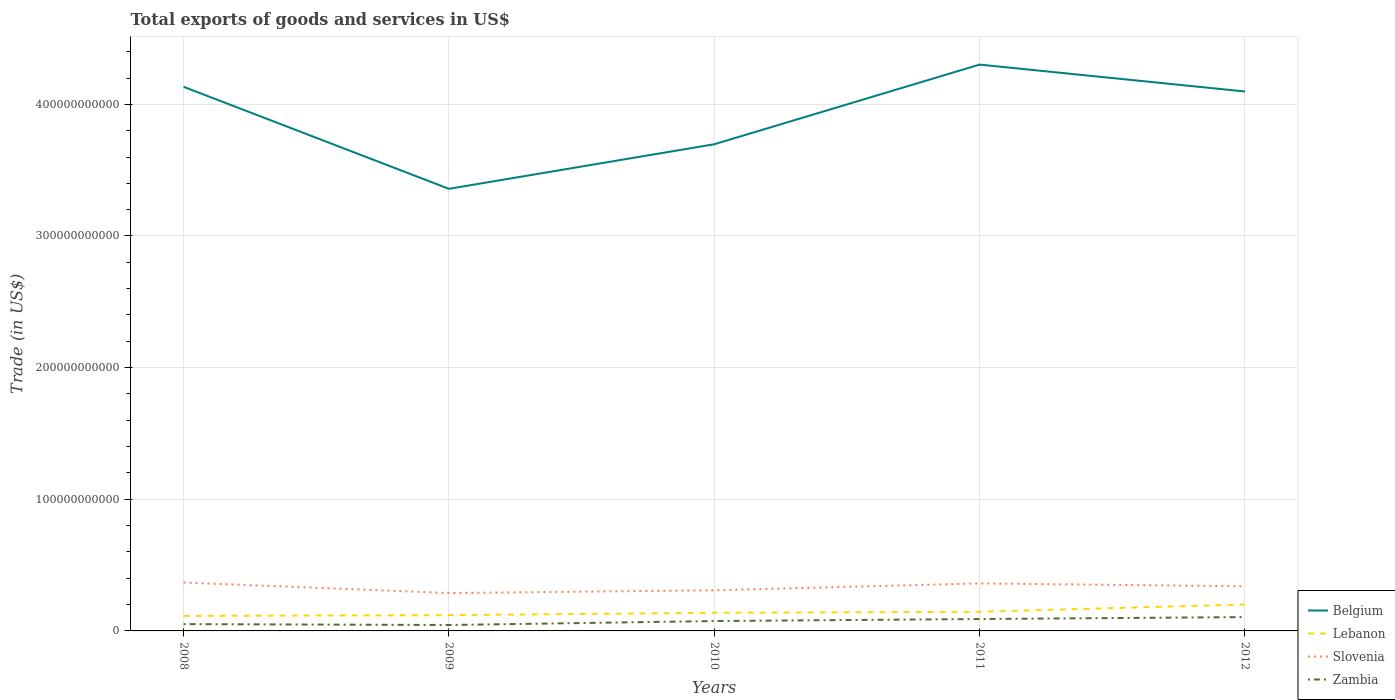Does the line corresponding to Belgium intersect with the line corresponding to Slovenia?
Your answer should be very brief. No. Is the number of lines equal to the number of legend labels?
Provide a succinct answer. Yes. Across all years, what is the maximum total exports of goods and services in Belgium?
Keep it short and to the point. 3.36e+11. In which year was the total exports of goods and services in Belgium maximum?
Provide a short and direct response. 2009. What is the total total exports of goods and services in Lebanon in the graph?
Your response must be concise. -3.09e+09. What is the difference between the highest and the second highest total exports of goods and services in Zambia?
Provide a short and direct response. 6.03e+09. What is the difference between two consecutive major ticks on the Y-axis?
Your answer should be very brief. 1.00e+11. Does the graph contain grids?
Offer a terse response. Yes. Where does the legend appear in the graph?
Provide a short and direct response. Bottom right. How are the legend labels stacked?
Give a very brief answer. Vertical. What is the title of the graph?
Offer a terse response. Total exports of goods and services in US$. Does "Turkey" appear as one of the legend labels in the graph?
Your answer should be compact. No. What is the label or title of the X-axis?
Make the answer very short. Years. What is the label or title of the Y-axis?
Ensure brevity in your answer.  Trade (in US$). What is the Trade (in US$) in Belgium in 2008?
Make the answer very short. 4.13e+11. What is the Trade (in US$) of Lebanon in 2008?
Make the answer very short. 1.14e+1. What is the Trade (in US$) of Slovenia in 2008?
Ensure brevity in your answer.  3.67e+1. What is the Trade (in US$) of Zambia in 2008?
Give a very brief answer. 5.18e+09. What is the Trade (in US$) of Belgium in 2009?
Offer a very short reply. 3.36e+11. What is the Trade (in US$) of Lebanon in 2009?
Keep it short and to the point. 1.20e+1. What is the Trade (in US$) in Slovenia in 2009?
Keep it short and to the point. 2.88e+1. What is the Trade (in US$) in Zambia in 2009?
Ensure brevity in your answer.  4.48e+09. What is the Trade (in US$) of Belgium in 2010?
Offer a very short reply. 3.70e+11. What is the Trade (in US$) in Lebanon in 2010?
Give a very brief answer. 1.38e+1. What is the Trade (in US$) in Slovenia in 2010?
Offer a very short reply. 3.09e+1. What is the Trade (in US$) of Zambia in 2010?
Your answer should be very brief. 7.50e+09. What is the Trade (in US$) in Belgium in 2011?
Your answer should be very brief. 4.30e+11. What is the Trade (in US$) of Lebanon in 2011?
Your response must be concise. 1.45e+1. What is the Trade (in US$) of Slovenia in 2011?
Ensure brevity in your answer.  3.61e+1. What is the Trade (in US$) of Zambia in 2011?
Your response must be concise. 9.03e+09. What is the Trade (in US$) in Belgium in 2012?
Your answer should be very brief. 4.10e+11. What is the Trade (in US$) of Lebanon in 2012?
Provide a succinct answer. 2.01e+1. What is the Trade (in US$) in Slovenia in 2012?
Provide a succinct answer. 3.39e+1. What is the Trade (in US$) in Zambia in 2012?
Ensure brevity in your answer.  1.05e+1. Across all years, what is the maximum Trade (in US$) in Belgium?
Your answer should be very brief. 4.30e+11. Across all years, what is the maximum Trade (in US$) in Lebanon?
Make the answer very short. 2.01e+1. Across all years, what is the maximum Trade (in US$) in Slovenia?
Provide a succinct answer. 3.67e+1. Across all years, what is the maximum Trade (in US$) in Zambia?
Give a very brief answer. 1.05e+1. Across all years, what is the minimum Trade (in US$) of Belgium?
Your answer should be very brief. 3.36e+11. Across all years, what is the minimum Trade (in US$) of Lebanon?
Provide a succinct answer. 1.14e+1. Across all years, what is the minimum Trade (in US$) of Slovenia?
Offer a terse response. 2.88e+1. Across all years, what is the minimum Trade (in US$) in Zambia?
Provide a succinct answer. 4.48e+09. What is the total Trade (in US$) in Belgium in the graph?
Give a very brief answer. 1.96e+12. What is the total Trade (in US$) of Lebanon in the graph?
Ensure brevity in your answer.  7.18e+1. What is the total Trade (in US$) of Slovenia in the graph?
Your answer should be compact. 1.66e+11. What is the total Trade (in US$) of Zambia in the graph?
Offer a very short reply. 3.67e+1. What is the difference between the Trade (in US$) of Belgium in 2008 and that in 2009?
Make the answer very short. 7.75e+1. What is the difference between the Trade (in US$) in Lebanon in 2008 and that in 2009?
Make the answer very short. -5.57e+08. What is the difference between the Trade (in US$) in Slovenia in 2008 and that in 2009?
Ensure brevity in your answer.  7.99e+09. What is the difference between the Trade (in US$) in Zambia in 2008 and that in 2009?
Your response must be concise. 6.96e+08. What is the difference between the Trade (in US$) of Belgium in 2008 and that in 2010?
Offer a very short reply. 4.36e+1. What is the difference between the Trade (in US$) of Lebanon in 2008 and that in 2010?
Your response must be concise. -2.35e+09. What is the difference between the Trade (in US$) of Slovenia in 2008 and that in 2010?
Provide a short and direct response. 5.88e+09. What is the difference between the Trade (in US$) of Zambia in 2008 and that in 2010?
Keep it short and to the point. -2.32e+09. What is the difference between the Trade (in US$) of Belgium in 2008 and that in 2011?
Make the answer very short. -1.69e+1. What is the difference between the Trade (in US$) of Lebanon in 2008 and that in 2011?
Offer a very short reply. -3.09e+09. What is the difference between the Trade (in US$) of Slovenia in 2008 and that in 2011?
Keep it short and to the point. 6.57e+08. What is the difference between the Trade (in US$) in Zambia in 2008 and that in 2011?
Your response must be concise. -3.85e+09. What is the difference between the Trade (in US$) in Belgium in 2008 and that in 2012?
Make the answer very short. 3.54e+09. What is the difference between the Trade (in US$) of Lebanon in 2008 and that in 2012?
Make the answer very short. -8.68e+09. What is the difference between the Trade (in US$) in Slovenia in 2008 and that in 2012?
Provide a succinct answer. 2.85e+09. What is the difference between the Trade (in US$) of Zambia in 2008 and that in 2012?
Give a very brief answer. -5.33e+09. What is the difference between the Trade (in US$) in Belgium in 2009 and that in 2010?
Keep it short and to the point. -3.38e+1. What is the difference between the Trade (in US$) in Lebanon in 2009 and that in 2010?
Offer a very short reply. -1.79e+09. What is the difference between the Trade (in US$) in Slovenia in 2009 and that in 2010?
Provide a succinct answer. -2.11e+09. What is the difference between the Trade (in US$) of Zambia in 2009 and that in 2010?
Provide a short and direct response. -3.02e+09. What is the difference between the Trade (in US$) in Belgium in 2009 and that in 2011?
Offer a terse response. -9.44e+1. What is the difference between the Trade (in US$) of Lebanon in 2009 and that in 2011?
Ensure brevity in your answer.  -2.53e+09. What is the difference between the Trade (in US$) of Slovenia in 2009 and that in 2011?
Provide a short and direct response. -7.33e+09. What is the difference between the Trade (in US$) in Zambia in 2009 and that in 2011?
Your response must be concise. -4.55e+09. What is the difference between the Trade (in US$) of Belgium in 2009 and that in 2012?
Your answer should be compact. -7.39e+1. What is the difference between the Trade (in US$) in Lebanon in 2009 and that in 2012?
Your response must be concise. -8.13e+09. What is the difference between the Trade (in US$) in Slovenia in 2009 and that in 2012?
Make the answer very short. -5.13e+09. What is the difference between the Trade (in US$) in Zambia in 2009 and that in 2012?
Your answer should be compact. -6.03e+09. What is the difference between the Trade (in US$) in Belgium in 2010 and that in 2011?
Give a very brief answer. -6.05e+1. What is the difference between the Trade (in US$) in Lebanon in 2010 and that in 2011?
Offer a terse response. -7.36e+08. What is the difference between the Trade (in US$) of Slovenia in 2010 and that in 2011?
Provide a short and direct response. -5.22e+09. What is the difference between the Trade (in US$) of Zambia in 2010 and that in 2011?
Offer a very short reply. -1.53e+09. What is the difference between the Trade (in US$) in Belgium in 2010 and that in 2012?
Make the answer very short. -4.01e+1. What is the difference between the Trade (in US$) of Lebanon in 2010 and that in 2012?
Make the answer very short. -6.33e+09. What is the difference between the Trade (in US$) of Slovenia in 2010 and that in 2012?
Your response must be concise. -3.03e+09. What is the difference between the Trade (in US$) in Zambia in 2010 and that in 2012?
Make the answer very short. -3.01e+09. What is the difference between the Trade (in US$) of Belgium in 2011 and that in 2012?
Make the answer very short. 2.04e+1. What is the difference between the Trade (in US$) of Lebanon in 2011 and that in 2012?
Your answer should be compact. -5.60e+09. What is the difference between the Trade (in US$) of Slovenia in 2011 and that in 2012?
Give a very brief answer. 2.20e+09. What is the difference between the Trade (in US$) of Zambia in 2011 and that in 2012?
Make the answer very short. -1.48e+09. What is the difference between the Trade (in US$) in Belgium in 2008 and the Trade (in US$) in Lebanon in 2009?
Your response must be concise. 4.01e+11. What is the difference between the Trade (in US$) of Belgium in 2008 and the Trade (in US$) of Slovenia in 2009?
Provide a succinct answer. 3.85e+11. What is the difference between the Trade (in US$) in Belgium in 2008 and the Trade (in US$) in Zambia in 2009?
Keep it short and to the point. 4.09e+11. What is the difference between the Trade (in US$) in Lebanon in 2008 and the Trade (in US$) in Slovenia in 2009?
Your answer should be very brief. -1.73e+1. What is the difference between the Trade (in US$) of Lebanon in 2008 and the Trade (in US$) of Zambia in 2009?
Offer a terse response. 6.95e+09. What is the difference between the Trade (in US$) in Slovenia in 2008 and the Trade (in US$) in Zambia in 2009?
Offer a terse response. 3.23e+1. What is the difference between the Trade (in US$) in Belgium in 2008 and the Trade (in US$) in Lebanon in 2010?
Your answer should be compact. 4.00e+11. What is the difference between the Trade (in US$) in Belgium in 2008 and the Trade (in US$) in Slovenia in 2010?
Offer a terse response. 3.82e+11. What is the difference between the Trade (in US$) in Belgium in 2008 and the Trade (in US$) in Zambia in 2010?
Provide a succinct answer. 4.06e+11. What is the difference between the Trade (in US$) in Lebanon in 2008 and the Trade (in US$) in Slovenia in 2010?
Your answer should be very brief. -1.94e+1. What is the difference between the Trade (in US$) in Lebanon in 2008 and the Trade (in US$) in Zambia in 2010?
Your answer should be very brief. 3.93e+09. What is the difference between the Trade (in US$) in Slovenia in 2008 and the Trade (in US$) in Zambia in 2010?
Provide a short and direct response. 2.92e+1. What is the difference between the Trade (in US$) of Belgium in 2008 and the Trade (in US$) of Lebanon in 2011?
Ensure brevity in your answer.  3.99e+11. What is the difference between the Trade (in US$) of Belgium in 2008 and the Trade (in US$) of Slovenia in 2011?
Provide a succinct answer. 3.77e+11. What is the difference between the Trade (in US$) in Belgium in 2008 and the Trade (in US$) in Zambia in 2011?
Offer a very short reply. 4.04e+11. What is the difference between the Trade (in US$) of Lebanon in 2008 and the Trade (in US$) of Slovenia in 2011?
Provide a short and direct response. -2.47e+1. What is the difference between the Trade (in US$) of Lebanon in 2008 and the Trade (in US$) of Zambia in 2011?
Ensure brevity in your answer.  2.40e+09. What is the difference between the Trade (in US$) in Slovenia in 2008 and the Trade (in US$) in Zambia in 2011?
Your answer should be compact. 2.77e+1. What is the difference between the Trade (in US$) of Belgium in 2008 and the Trade (in US$) of Lebanon in 2012?
Make the answer very short. 3.93e+11. What is the difference between the Trade (in US$) in Belgium in 2008 and the Trade (in US$) in Slovenia in 2012?
Your answer should be very brief. 3.79e+11. What is the difference between the Trade (in US$) in Belgium in 2008 and the Trade (in US$) in Zambia in 2012?
Your answer should be compact. 4.03e+11. What is the difference between the Trade (in US$) of Lebanon in 2008 and the Trade (in US$) of Slovenia in 2012?
Make the answer very short. -2.25e+1. What is the difference between the Trade (in US$) in Lebanon in 2008 and the Trade (in US$) in Zambia in 2012?
Give a very brief answer. 9.21e+08. What is the difference between the Trade (in US$) of Slovenia in 2008 and the Trade (in US$) of Zambia in 2012?
Provide a succinct answer. 2.62e+1. What is the difference between the Trade (in US$) of Belgium in 2009 and the Trade (in US$) of Lebanon in 2010?
Offer a very short reply. 3.22e+11. What is the difference between the Trade (in US$) of Belgium in 2009 and the Trade (in US$) of Slovenia in 2010?
Make the answer very short. 3.05e+11. What is the difference between the Trade (in US$) in Belgium in 2009 and the Trade (in US$) in Zambia in 2010?
Offer a very short reply. 3.28e+11. What is the difference between the Trade (in US$) in Lebanon in 2009 and the Trade (in US$) in Slovenia in 2010?
Your answer should be compact. -1.89e+1. What is the difference between the Trade (in US$) in Lebanon in 2009 and the Trade (in US$) in Zambia in 2010?
Offer a very short reply. 4.48e+09. What is the difference between the Trade (in US$) of Slovenia in 2009 and the Trade (in US$) of Zambia in 2010?
Provide a short and direct response. 2.13e+1. What is the difference between the Trade (in US$) in Belgium in 2009 and the Trade (in US$) in Lebanon in 2011?
Give a very brief answer. 3.21e+11. What is the difference between the Trade (in US$) in Belgium in 2009 and the Trade (in US$) in Slovenia in 2011?
Your answer should be very brief. 3.00e+11. What is the difference between the Trade (in US$) of Belgium in 2009 and the Trade (in US$) of Zambia in 2011?
Your answer should be very brief. 3.27e+11. What is the difference between the Trade (in US$) of Lebanon in 2009 and the Trade (in US$) of Slovenia in 2011?
Offer a very short reply. -2.41e+1. What is the difference between the Trade (in US$) in Lebanon in 2009 and the Trade (in US$) in Zambia in 2011?
Make the answer very short. 2.95e+09. What is the difference between the Trade (in US$) in Slovenia in 2009 and the Trade (in US$) in Zambia in 2011?
Provide a succinct answer. 1.97e+1. What is the difference between the Trade (in US$) of Belgium in 2009 and the Trade (in US$) of Lebanon in 2012?
Offer a very short reply. 3.16e+11. What is the difference between the Trade (in US$) of Belgium in 2009 and the Trade (in US$) of Slovenia in 2012?
Your answer should be very brief. 3.02e+11. What is the difference between the Trade (in US$) in Belgium in 2009 and the Trade (in US$) in Zambia in 2012?
Make the answer very short. 3.25e+11. What is the difference between the Trade (in US$) in Lebanon in 2009 and the Trade (in US$) in Slovenia in 2012?
Provide a succinct answer. -2.19e+1. What is the difference between the Trade (in US$) in Lebanon in 2009 and the Trade (in US$) in Zambia in 2012?
Offer a very short reply. 1.48e+09. What is the difference between the Trade (in US$) in Slovenia in 2009 and the Trade (in US$) in Zambia in 2012?
Your response must be concise. 1.83e+1. What is the difference between the Trade (in US$) of Belgium in 2010 and the Trade (in US$) of Lebanon in 2011?
Offer a very short reply. 3.55e+11. What is the difference between the Trade (in US$) of Belgium in 2010 and the Trade (in US$) of Slovenia in 2011?
Keep it short and to the point. 3.34e+11. What is the difference between the Trade (in US$) of Belgium in 2010 and the Trade (in US$) of Zambia in 2011?
Your answer should be very brief. 3.61e+11. What is the difference between the Trade (in US$) of Lebanon in 2010 and the Trade (in US$) of Slovenia in 2011?
Your response must be concise. -2.23e+1. What is the difference between the Trade (in US$) of Lebanon in 2010 and the Trade (in US$) of Zambia in 2011?
Your answer should be very brief. 4.75e+09. What is the difference between the Trade (in US$) in Slovenia in 2010 and the Trade (in US$) in Zambia in 2011?
Keep it short and to the point. 2.18e+1. What is the difference between the Trade (in US$) in Belgium in 2010 and the Trade (in US$) in Lebanon in 2012?
Ensure brevity in your answer.  3.50e+11. What is the difference between the Trade (in US$) of Belgium in 2010 and the Trade (in US$) of Slovenia in 2012?
Ensure brevity in your answer.  3.36e+11. What is the difference between the Trade (in US$) in Belgium in 2010 and the Trade (in US$) in Zambia in 2012?
Ensure brevity in your answer.  3.59e+11. What is the difference between the Trade (in US$) in Lebanon in 2010 and the Trade (in US$) in Slovenia in 2012?
Offer a very short reply. -2.01e+1. What is the difference between the Trade (in US$) of Lebanon in 2010 and the Trade (in US$) of Zambia in 2012?
Your response must be concise. 3.27e+09. What is the difference between the Trade (in US$) of Slovenia in 2010 and the Trade (in US$) of Zambia in 2012?
Your answer should be compact. 2.04e+1. What is the difference between the Trade (in US$) of Belgium in 2011 and the Trade (in US$) of Lebanon in 2012?
Provide a short and direct response. 4.10e+11. What is the difference between the Trade (in US$) in Belgium in 2011 and the Trade (in US$) in Slovenia in 2012?
Keep it short and to the point. 3.96e+11. What is the difference between the Trade (in US$) of Belgium in 2011 and the Trade (in US$) of Zambia in 2012?
Offer a very short reply. 4.20e+11. What is the difference between the Trade (in US$) in Lebanon in 2011 and the Trade (in US$) in Slovenia in 2012?
Offer a very short reply. -1.94e+1. What is the difference between the Trade (in US$) in Lebanon in 2011 and the Trade (in US$) in Zambia in 2012?
Ensure brevity in your answer.  4.01e+09. What is the difference between the Trade (in US$) of Slovenia in 2011 and the Trade (in US$) of Zambia in 2012?
Ensure brevity in your answer.  2.56e+1. What is the average Trade (in US$) in Belgium per year?
Make the answer very short. 3.92e+11. What is the average Trade (in US$) in Lebanon per year?
Give a very brief answer. 1.44e+1. What is the average Trade (in US$) in Slovenia per year?
Provide a succinct answer. 3.33e+1. What is the average Trade (in US$) in Zambia per year?
Your answer should be very brief. 7.34e+09. In the year 2008, what is the difference between the Trade (in US$) of Belgium and Trade (in US$) of Lebanon?
Ensure brevity in your answer.  4.02e+11. In the year 2008, what is the difference between the Trade (in US$) in Belgium and Trade (in US$) in Slovenia?
Offer a terse response. 3.77e+11. In the year 2008, what is the difference between the Trade (in US$) of Belgium and Trade (in US$) of Zambia?
Offer a very short reply. 4.08e+11. In the year 2008, what is the difference between the Trade (in US$) of Lebanon and Trade (in US$) of Slovenia?
Give a very brief answer. -2.53e+1. In the year 2008, what is the difference between the Trade (in US$) of Lebanon and Trade (in US$) of Zambia?
Ensure brevity in your answer.  6.25e+09. In the year 2008, what is the difference between the Trade (in US$) in Slovenia and Trade (in US$) in Zambia?
Provide a succinct answer. 3.16e+1. In the year 2009, what is the difference between the Trade (in US$) of Belgium and Trade (in US$) of Lebanon?
Provide a succinct answer. 3.24e+11. In the year 2009, what is the difference between the Trade (in US$) of Belgium and Trade (in US$) of Slovenia?
Keep it short and to the point. 3.07e+11. In the year 2009, what is the difference between the Trade (in US$) of Belgium and Trade (in US$) of Zambia?
Keep it short and to the point. 3.31e+11. In the year 2009, what is the difference between the Trade (in US$) in Lebanon and Trade (in US$) in Slovenia?
Give a very brief answer. -1.68e+1. In the year 2009, what is the difference between the Trade (in US$) in Lebanon and Trade (in US$) in Zambia?
Ensure brevity in your answer.  7.50e+09. In the year 2009, what is the difference between the Trade (in US$) of Slovenia and Trade (in US$) of Zambia?
Make the answer very short. 2.43e+1. In the year 2010, what is the difference between the Trade (in US$) of Belgium and Trade (in US$) of Lebanon?
Make the answer very short. 3.56e+11. In the year 2010, what is the difference between the Trade (in US$) of Belgium and Trade (in US$) of Slovenia?
Your answer should be very brief. 3.39e+11. In the year 2010, what is the difference between the Trade (in US$) in Belgium and Trade (in US$) in Zambia?
Your answer should be very brief. 3.62e+11. In the year 2010, what is the difference between the Trade (in US$) of Lebanon and Trade (in US$) of Slovenia?
Offer a terse response. -1.71e+1. In the year 2010, what is the difference between the Trade (in US$) in Lebanon and Trade (in US$) in Zambia?
Keep it short and to the point. 6.28e+09. In the year 2010, what is the difference between the Trade (in US$) in Slovenia and Trade (in US$) in Zambia?
Your response must be concise. 2.34e+1. In the year 2011, what is the difference between the Trade (in US$) in Belgium and Trade (in US$) in Lebanon?
Keep it short and to the point. 4.16e+11. In the year 2011, what is the difference between the Trade (in US$) in Belgium and Trade (in US$) in Slovenia?
Provide a succinct answer. 3.94e+11. In the year 2011, what is the difference between the Trade (in US$) of Belgium and Trade (in US$) of Zambia?
Your answer should be compact. 4.21e+11. In the year 2011, what is the difference between the Trade (in US$) of Lebanon and Trade (in US$) of Slovenia?
Ensure brevity in your answer.  -2.16e+1. In the year 2011, what is the difference between the Trade (in US$) of Lebanon and Trade (in US$) of Zambia?
Offer a terse response. 5.48e+09. In the year 2011, what is the difference between the Trade (in US$) of Slovenia and Trade (in US$) of Zambia?
Keep it short and to the point. 2.71e+1. In the year 2012, what is the difference between the Trade (in US$) in Belgium and Trade (in US$) in Lebanon?
Provide a short and direct response. 3.90e+11. In the year 2012, what is the difference between the Trade (in US$) of Belgium and Trade (in US$) of Slovenia?
Offer a very short reply. 3.76e+11. In the year 2012, what is the difference between the Trade (in US$) in Belgium and Trade (in US$) in Zambia?
Ensure brevity in your answer.  3.99e+11. In the year 2012, what is the difference between the Trade (in US$) in Lebanon and Trade (in US$) in Slovenia?
Your answer should be compact. -1.38e+1. In the year 2012, what is the difference between the Trade (in US$) of Lebanon and Trade (in US$) of Zambia?
Your response must be concise. 9.61e+09. In the year 2012, what is the difference between the Trade (in US$) of Slovenia and Trade (in US$) of Zambia?
Your answer should be very brief. 2.34e+1. What is the ratio of the Trade (in US$) in Belgium in 2008 to that in 2009?
Offer a terse response. 1.23. What is the ratio of the Trade (in US$) in Lebanon in 2008 to that in 2009?
Offer a terse response. 0.95. What is the ratio of the Trade (in US$) in Slovenia in 2008 to that in 2009?
Your answer should be compact. 1.28. What is the ratio of the Trade (in US$) of Zambia in 2008 to that in 2009?
Make the answer very short. 1.16. What is the ratio of the Trade (in US$) in Belgium in 2008 to that in 2010?
Your answer should be compact. 1.12. What is the ratio of the Trade (in US$) of Lebanon in 2008 to that in 2010?
Offer a terse response. 0.83. What is the ratio of the Trade (in US$) of Slovenia in 2008 to that in 2010?
Keep it short and to the point. 1.19. What is the ratio of the Trade (in US$) in Zambia in 2008 to that in 2010?
Offer a terse response. 0.69. What is the ratio of the Trade (in US$) in Belgium in 2008 to that in 2011?
Provide a short and direct response. 0.96. What is the ratio of the Trade (in US$) of Lebanon in 2008 to that in 2011?
Keep it short and to the point. 0.79. What is the ratio of the Trade (in US$) of Slovenia in 2008 to that in 2011?
Provide a succinct answer. 1.02. What is the ratio of the Trade (in US$) in Zambia in 2008 to that in 2011?
Provide a short and direct response. 0.57. What is the ratio of the Trade (in US$) of Belgium in 2008 to that in 2012?
Give a very brief answer. 1.01. What is the ratio of the Trade (in US$) in Lebanon in 2008 to that in 2012?
Provide a short and direct response. 0.57. What is the ratio of the Trade (in US$) of Slovenia in 2008 to that in 2012?
Keep it short and to the point. 1.08. What is the ratio of the Trade (in US$) of Zambia in 2008 to that in 2012?
Give a very brief answer. 0.49. What is the ratio of the Trade (in US$) in Belgium in 2009 to that in 2010?
Ensure brevity in your answer.  0.91. What is the ratio of the Trade (in US$) of Lebanon in 2009 to that in 2010?
Provide a succinct answer. 0.87. What is the ratio of the Trade (in US$) of Slovenia in 2009 to that in 2010?
Give a very brief answer. 0.93. What is the ratio of the Trade (in US$) of Zambia in 2009 to that in 2010?
Your answer should be compact. 0.6. What is the ratio of the Trade (in US$) of Belgium in 2009 to that in 2011?
Your answer should be very brief. 0.78. What is the ratio of the Trade (in US$) in Lebanon in 2009 to that in 2011?
Your answer should be compact. 0.83. What is the ratio of the Trade (in US$) in Slovenia in 2009 to that in 2011?
Your answer should be compact. 0.8. What is the ratio of the Trade (in US$) of Zambia in 2009 to that in 2011?
Your answer should be compact. 0.5. What is the ratio of the Trade (in US$) of Belgium in 2009 to that in 2012?
Offer a very short reply. 0.82. What is the ratio of the Trade (in US$) of Lebanon in 2009 to that in 2012?
Make the answer very short. 0.6. What is the ratio of the Trade (in US$) of Slovenia in 2009 to that in 2012?
Keep it short and to the point. 0.85. What is the ratio of the Trade (in US$) in Zambia in 2009 to that in 2012?
Ensure brevity in your answer.  0.43. What is the ratio of the Trade (in US$) in Belgium in 2010 to that in 2011?
Ensure brevity in your answer.  0.86. What is the ratio of the Trade (in US$) in Lebanon in 2010 to that in 2011?
Make the answer very short. 0.95. What is the ratio of the Trade (in US$) of Slovenia in 2010 to that in 2011?
Make the answer very short. 0.86. What is the ratio of the Trade (in US$) in Zambia in 2010 to that in 2011?
Provide a short and direct response. 0.83. What is the ratio of the Trade (in US$) in Belgium in 2010 to that in 2012?
Ensure brevity in your answer.  0.9. What is the ratio of the Trade (in US$) in Lebanon in 2010 to that in 2012?
Ensure brevity in your answer.  0.69. What is the ratio of the Trade (in US$) of Slovenia in 2010 to that in 2012?
Your response must be concise. 0.91. What is the ratio of the Trade (in US$) in Zambia in 2010 to that in 2012?
Your answer should be very brief. 0.71. What is the ratio of the Trade (in US$) in Belgium in 2011 to that in 2012?
Your answer should be very brief. 1.05. What is the ratio of the Trade (in US$) of Lebanon in 2011 to that in 2012?
Make the answer very short. 0.72. What is the ratio of the Trade (in US$) of Slovenia in 2011 to that in 2012?
Provide a succinct answer. 1.06. What is the ratio of the Trade (in US$) of Zambia in 2011 to that in 2012?
Provide a succinct answer. 0.86. What is the difference between the highest and the second highest Trade (in US$) in Belgium?
Provide a short and direct response. 1.69e+1. What is the difference between the highest and the second highest Trade (in US$) in Lebanon?
Provide a succinct answer. 5.60e+09. What is the difference between the highest and the second highest Trade (in US$) of Slovenia?
Your response must be concise. 6.57e+08. What is the difference between the highest and the second highest Trade (in US$) of Zambia?
Offer a terse response. 1.48e+09. What is the difference between the highest and the lowest Trade (in US$) in Belgium?
Offer a terse response. 9.44e+1. What is the difference between the highest and the lowest Trade (in US$) of Lebanon?
Offer a very short reply. 8.68e+09. What is the difference between the highest and the lowest Trade (in US$) in Slovenia?
Your answer should be compact. 7.99e+09. What is the difference between the highest and the lowest Trade (in US$) of Zambia?
Provide a succinct answer. 6.03e+09. 